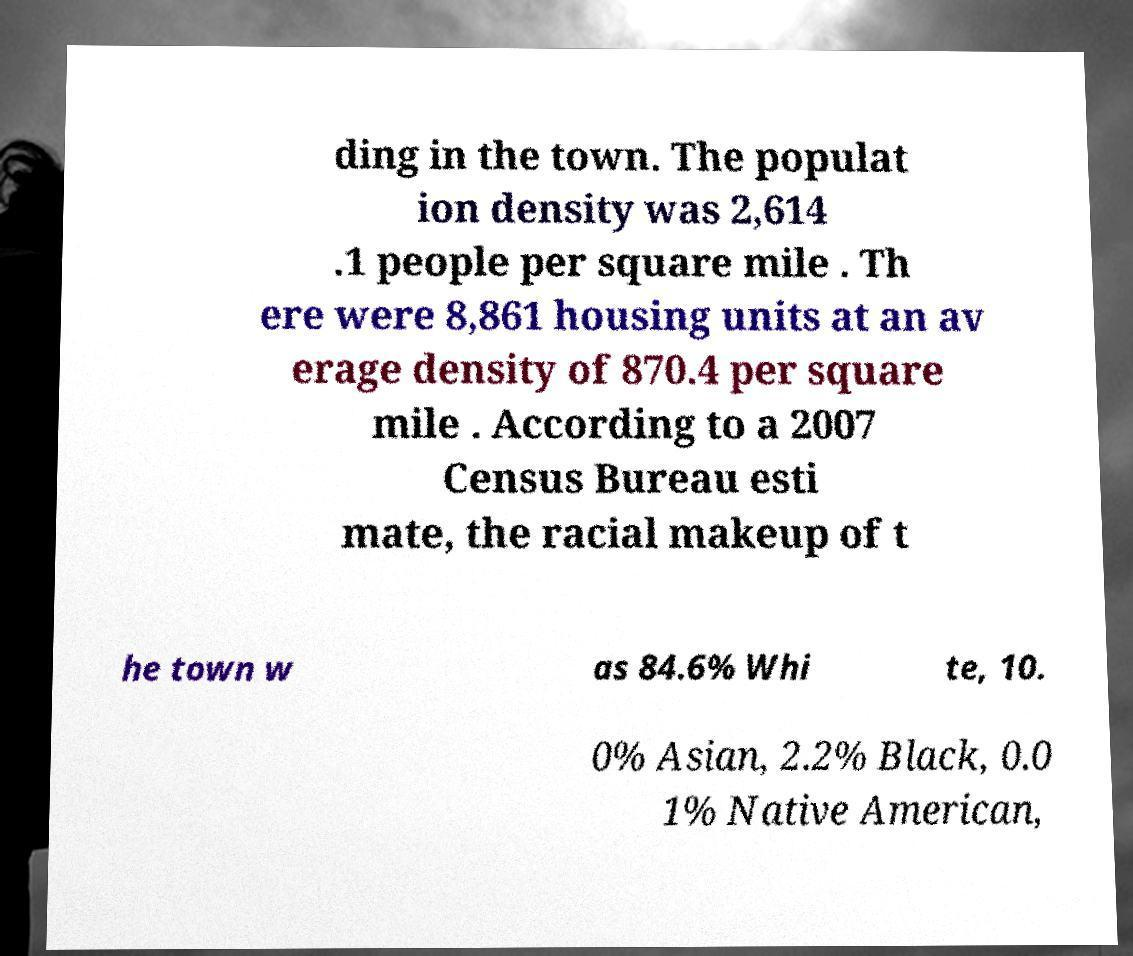For documentation purposes, I need the text within this image transcribed. Could you provide that? ding in the town. The populat ion density was 2,614 .1 people per square mile . Th ere were 8,861 housing units at an av erage density of 870.4 per square mile . According to a 2007 Census Bureau esti mate, the racial makeup of t he town w as 84.6% Whi te, 10. 0% Asian, 2.2% Black, 0.0 1% Native American, 